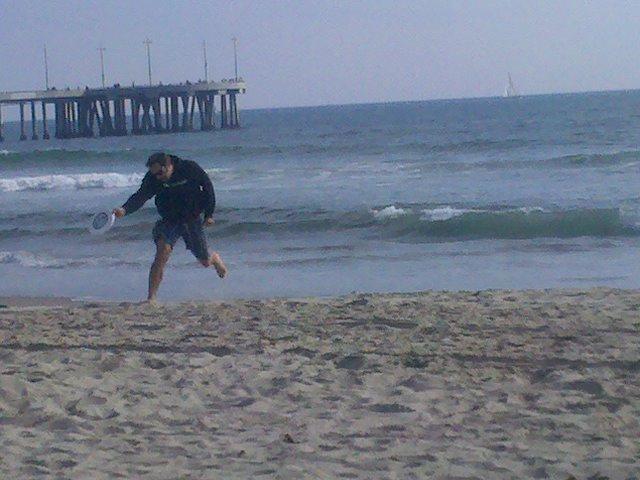Is he throwing or catching the Frisbee?
Quick response, please. Catching. What is the wooden structure seen in the water?
Be succinct. Pier. What is in the water?
Concise answer only. Pier. Is that a frisbee in his hand?
Be succinct. Yes. Is the man playing a game or in the midst of an interpretive dance?
Give a very brief answer. Playing game. Where is the people walking towards?
Concise answer only. Beach. 